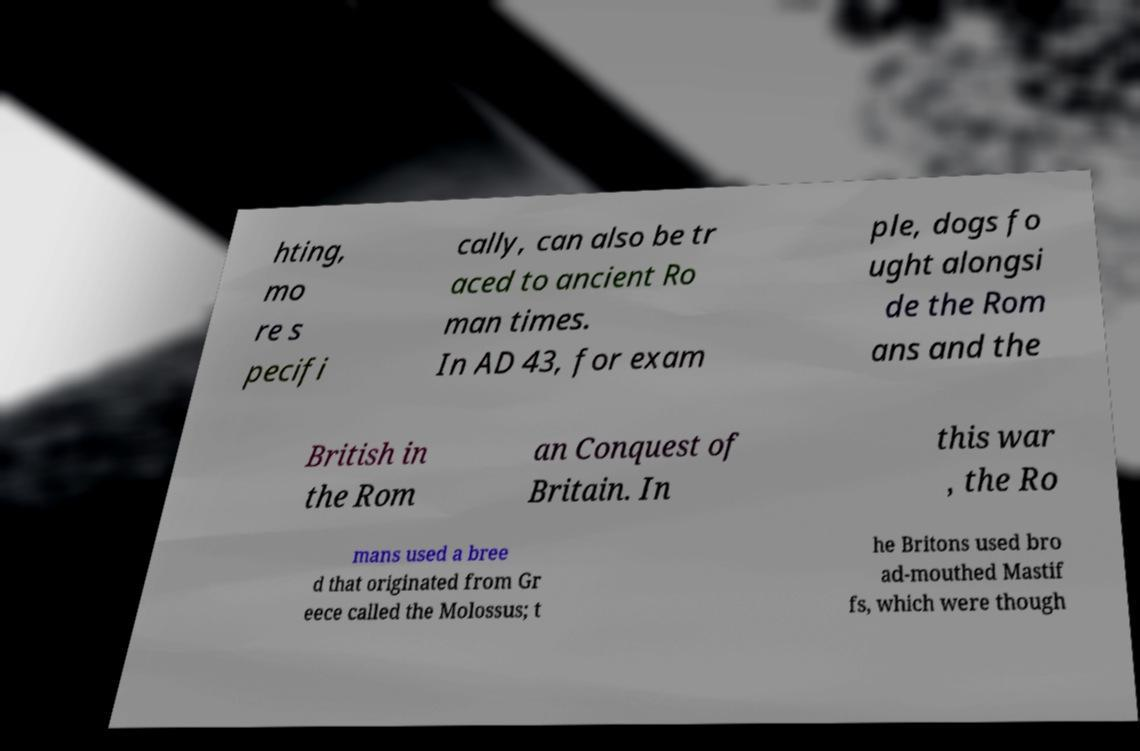I need the written content from this picture converted into text. Can you do that? hting, mo re s pecifi cally, can also be tr aced to ancient Ro man times. In AD 43, for exam ple, dogs fo ught alongsi de the Rom ans and the British in the Rom an Conquest of Britain. In this war , the Ro mans used a bree d that originated from Gr eece called the Molossus; t he Britons used bro ad-mouthed Mastif fs, which were though 